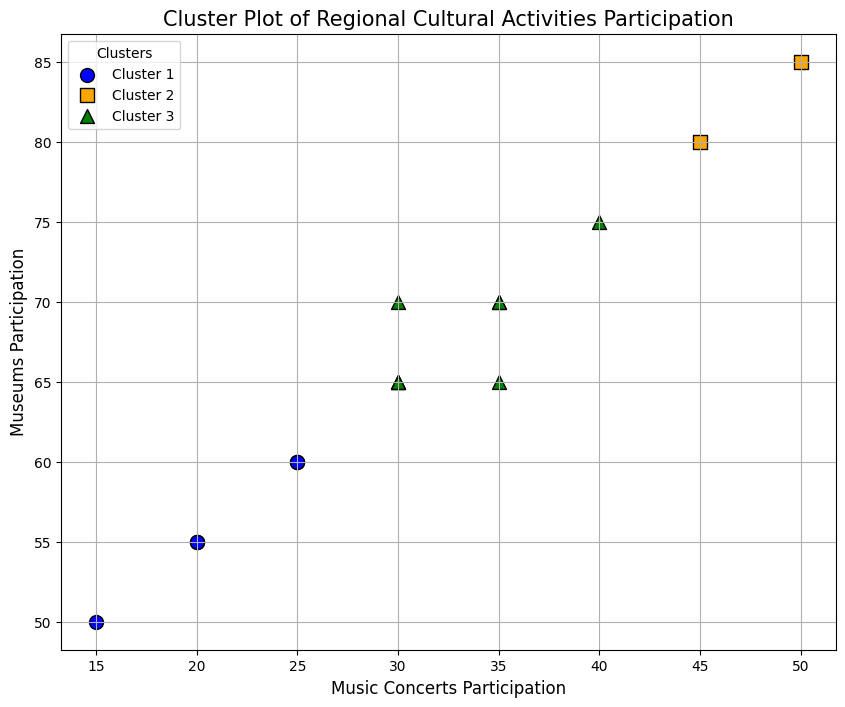What color represents Cluster 1? The plot legend shows that Cluster 1 is represented in blue. The blue scatter points in the plot indicate Cluster 1.
Answer: Blue Which cluster has the highest participation in Music Concerts? Observing the plot, the Community of Madrid data point has the highest value on the Music Concerts Participation axis and it is colored blue. Thus, Cluster 1 (blue) has the highest participation in Music Concerts.
Answer: Cluster 1 How many clusters are represented in the plot? The legend of the plot indicates three distinct clusters, each labeled with a different color.
Answer: Three Is there any cluster that has more participation in Museums than Cluster 2? Observing the plot, points colored in blue (Cluster 1) and orange (Cluster 2) need to be compared. The highest Museum participation is in Cluster 1, evident by the scattered point representing Community of Madrid.
Answer: Yes Which regional participating activity shows the highest spread in participation within any cluster? By examining the spread of points along both axes for each cluster, Cluster 1 (blue) exhibits a wide spread in Music Concerts and Museums participation. The vertical spread of blue points clearly exceeds that of others.
Answer: Music Concerts Which cluster contains the region with the lowest participation in Music Concerts? Observing the plot, the Extremadura region has the lowest value on the Music Concerts Participation axis and it is colored green, indicating it belongs to Cluster 3.
Answer: Cluster 3 Do any regions in Cluster 3 have higher Museum participation than regions in Cluster 1? Analyzing the plot, no green points (Cluster 3) are higher on the Museums Participation axis than the blue point representing Community of Madrid from Cluster 1.
Answer: No What is the average participation in Museums for Cluster 1? The vertical positions of the blue points illustrate the data for Cluster 1. Calculations based on the y-axis values for Museums Participation must be done: (65 for Andalusia + 75 for Basque Country + 80 for Catalonia + 85 for Community of Madrid + 70 for Galicia + 70 for Valencian Community) / 6 = 74.17.
Answer: 74.17 Which cluster has the least spread in Museum participation? By analyzing the width of the spread on the y-axis (Museums Participation), Cluster 2 (orange) points are the closest to each other compared to the other clusters.
Answer: Cluster 2 